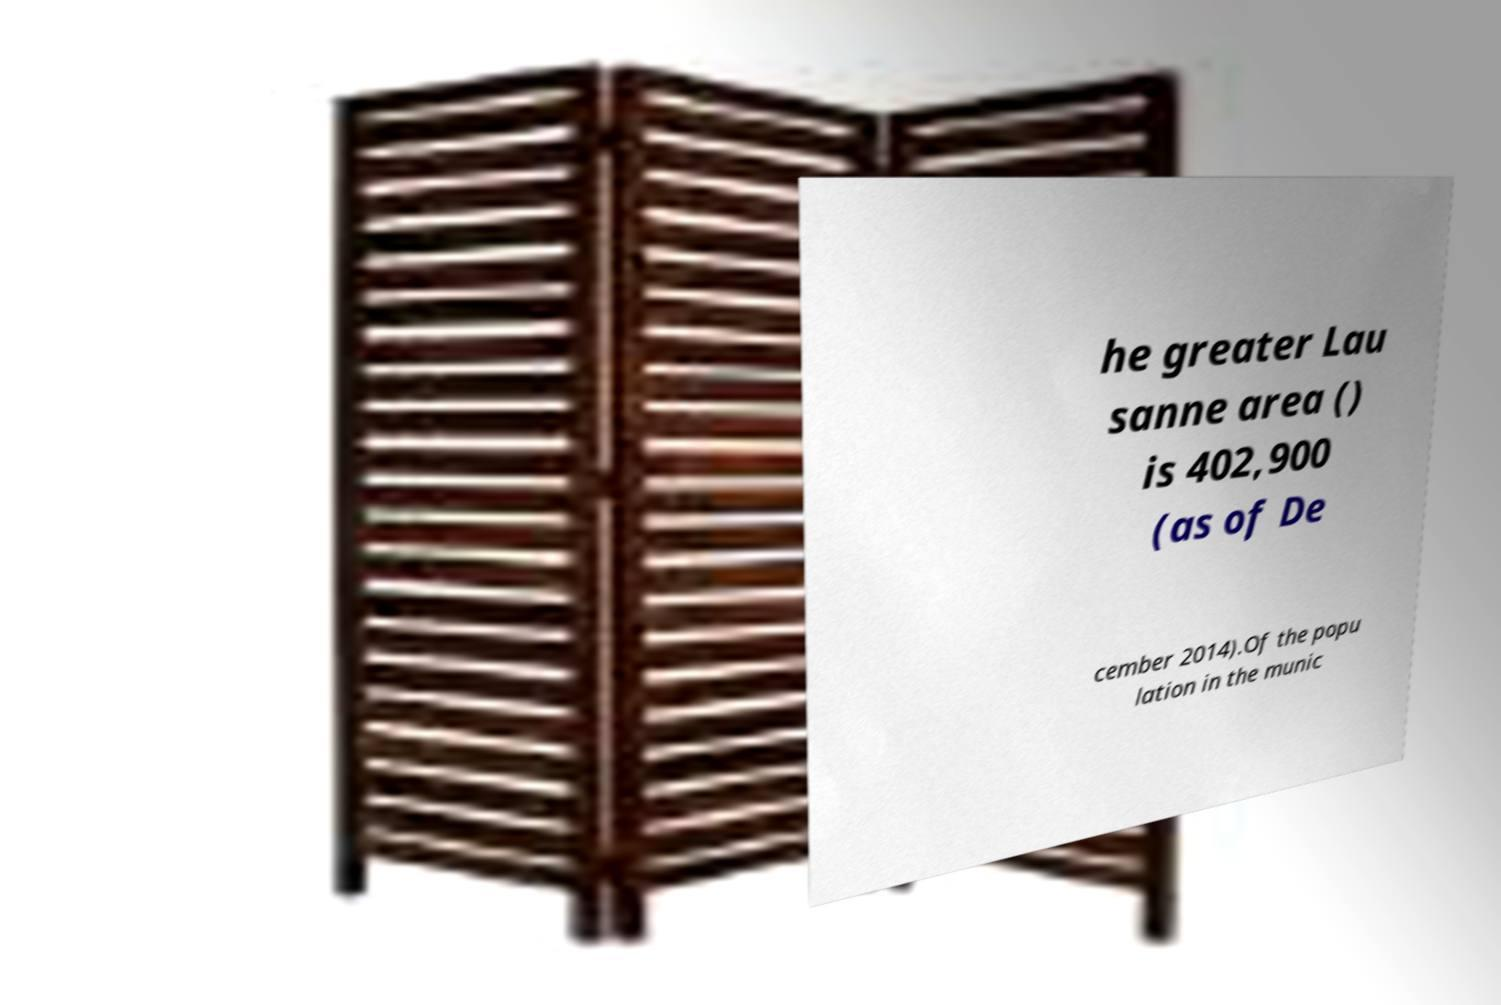Can you read and provide the text displayed in the image?This photo seems to have some interesting text. Can you extract and type it out for me? he greater Lau sanne area () is 402,900 (as of De cember 2014).Of the popu lation in the munic 